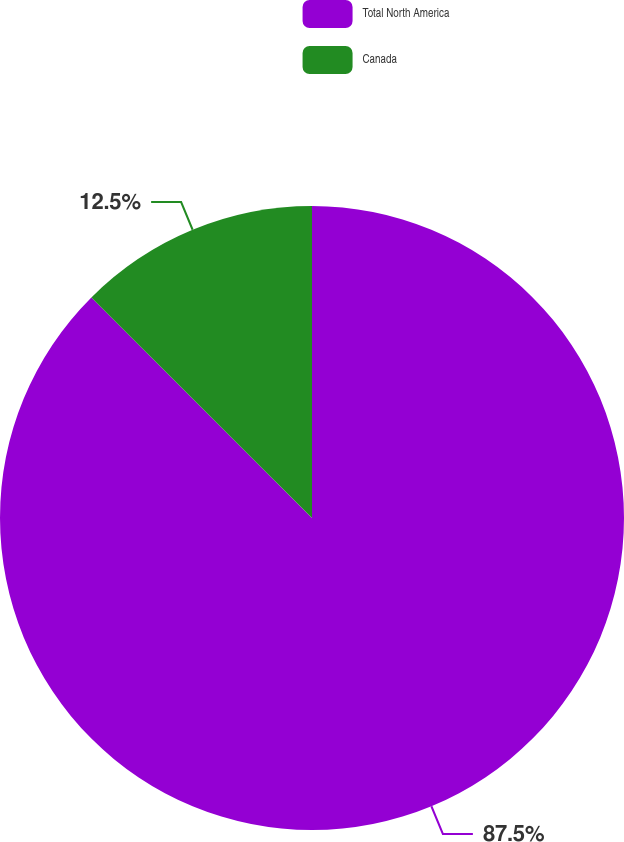Convert chart. <chart><loc_0><loc_0><loc_500><loc_500><pie_chart><fcel>Total North America<fcel>Canada<nl><fcel>87.5%<fcel>12.5%<nl></chart> 